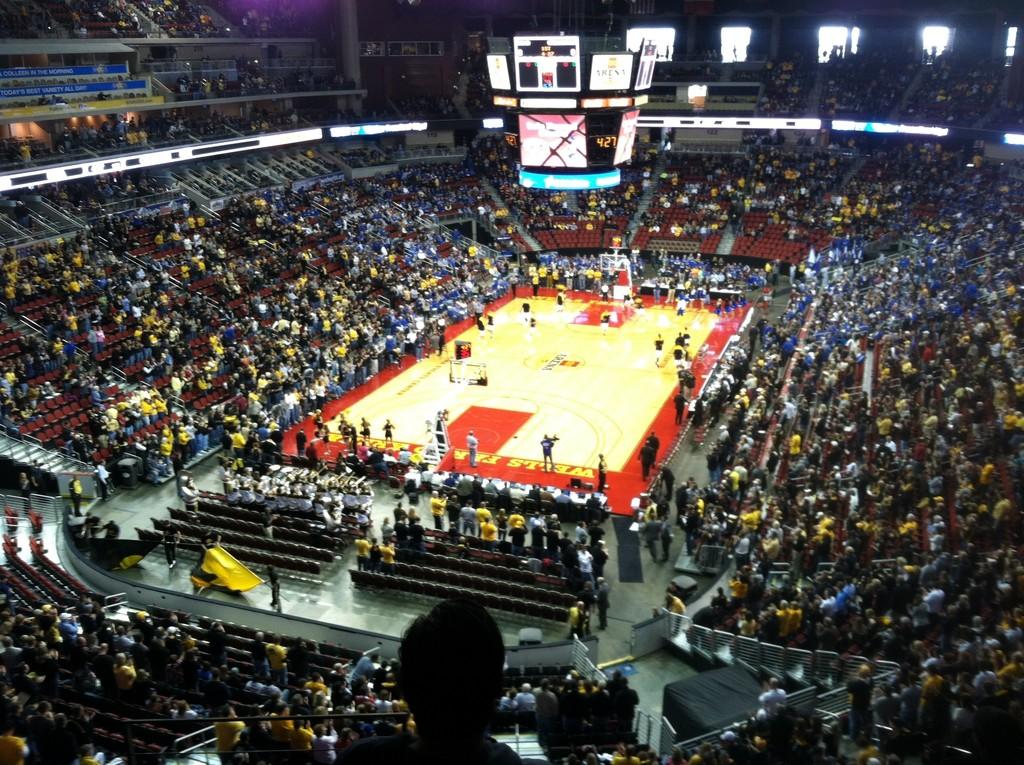What time is it in this picture?
Offer a very short reply. 4:27. What bank is written in yellow text on the basketball court?
Offer a very short reply. Wells fargo. 